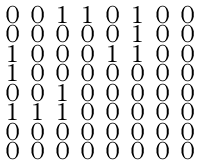<formula> <loc_0><loc_0><loc_500><loc_500>\begin{smallmatrix} 0 & 0 & 1 & 1 & 0 & 1 & 0 & 0 \\ 0 & 0 & 0 & 0 & 0 & 1 & 0 & 0 \\ 1 & 0 & 0 & 0 & 1 & 1 & 0 & 0 \\ 1 & 0 & 0 & 0 & 0 & 0 & 0 & 0 \\ 0 & 0 & 1 & 0 & 0 & 0 & 0 & 0 \\ 1 & 1 & 1 & 0 & 0 & 0 & 0 & 0 \\ 0 & 0 & 0 & 0 & 0 & 0 & 0 & 0 \\ 0 & 0 & 0 & 0 & 0 & 0 & 0 & 0 \end{smallmatrix}</formula> 